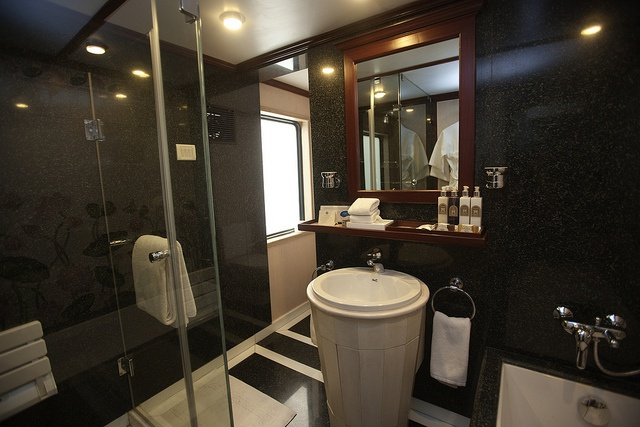Describe the objects in this image and their specific colors. I can see sink in black, tan, and gray tones, bottle in black, tan, maroon, and gray tones, bottle in black, maroon, and gray tones, bottle in black, tan, and gray tones, and bottle in black, tan, maroon, and gray tones in this image. 